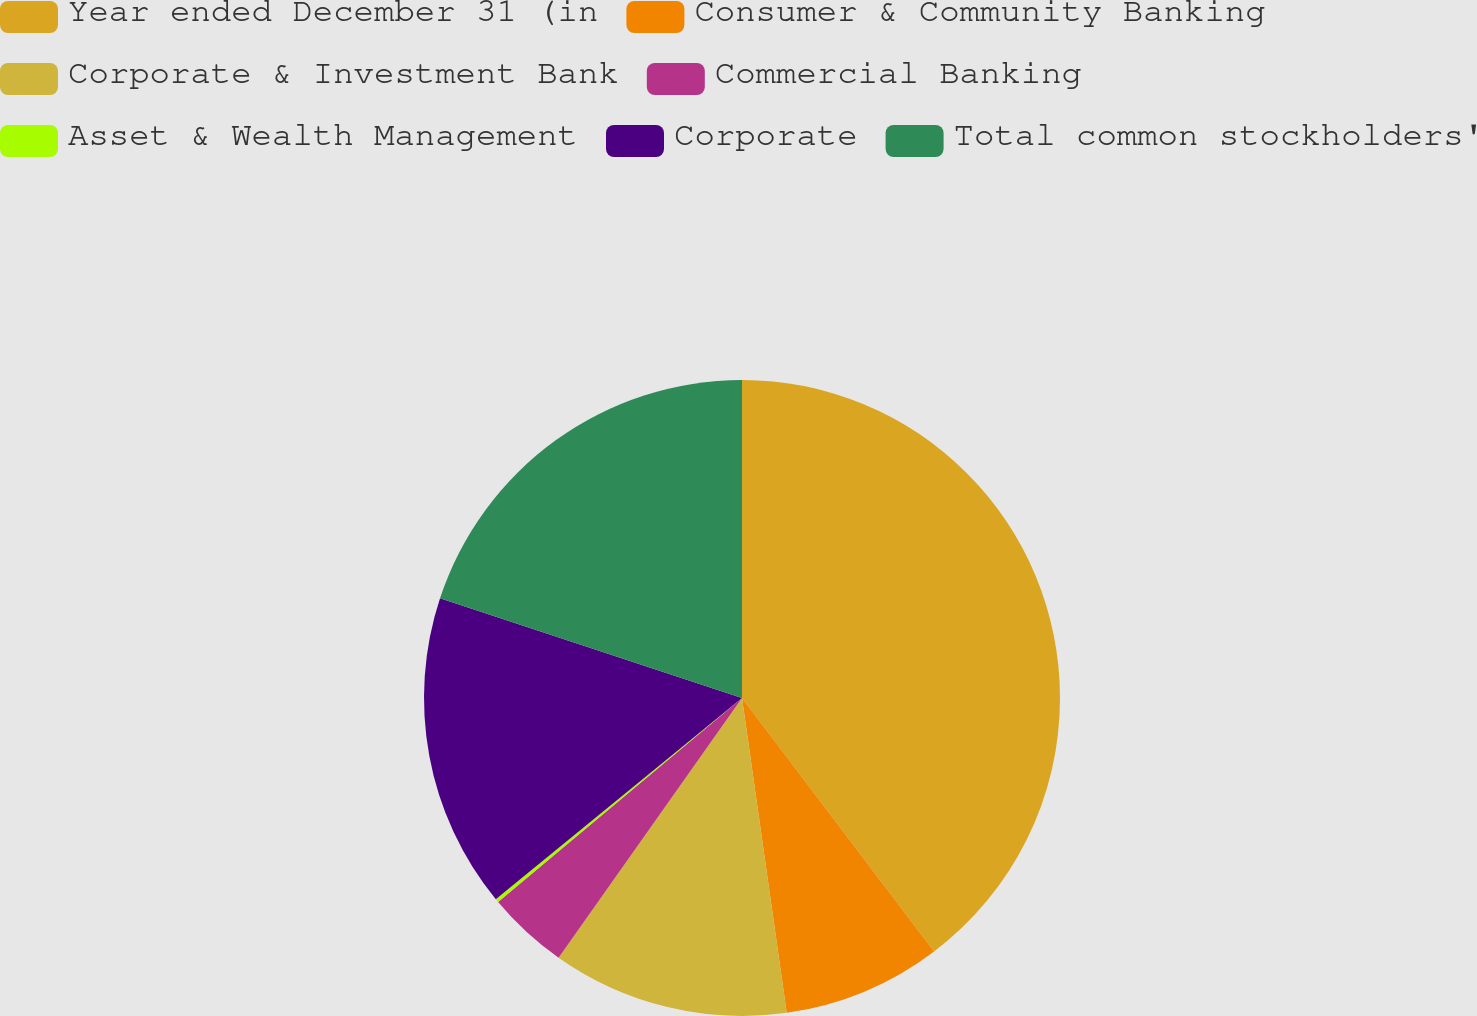Convert chart. <chart><loc_0><loc_0><loc_500><loc_500><pie_chart><fcel>Year ended December 31 (in<fcel>Consumer & Community Banking<fcel>Corporate & Investment Bank<fcel>Commercial Banking<fcel>Asset & Wealth Management<fcel>Corporate<fcel>Total common stockholders'<nl><fcel>39.68%<fcel>8.08%<fcel>12.03%<fcel>4.13%<fcel>0.18%<fcel>15.98%<fcel>19.93%<nl></chart> 